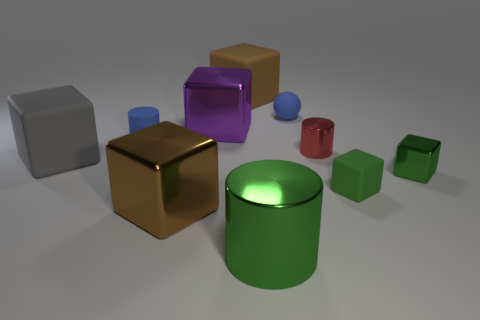Subtract all big purple shiny blocks. How many blocks are left? 5 Subtract all brown cubes. How many cubes are left? 4 Subtract all green blocks. Subtract all gray spheres. How many blocks are left? 4 Subtract all cubes. How many objects are left? 4 Add 2 big cyan matte cubes. How many big cyan matte cubes exist? 2 Subtract 0 green balls. How many objects are left? 10 Subtract all small blue rubber balls. Subtract all tiny blue matte things. How many objects are left? 7 Add 1 balls. How many balls are left? 2 